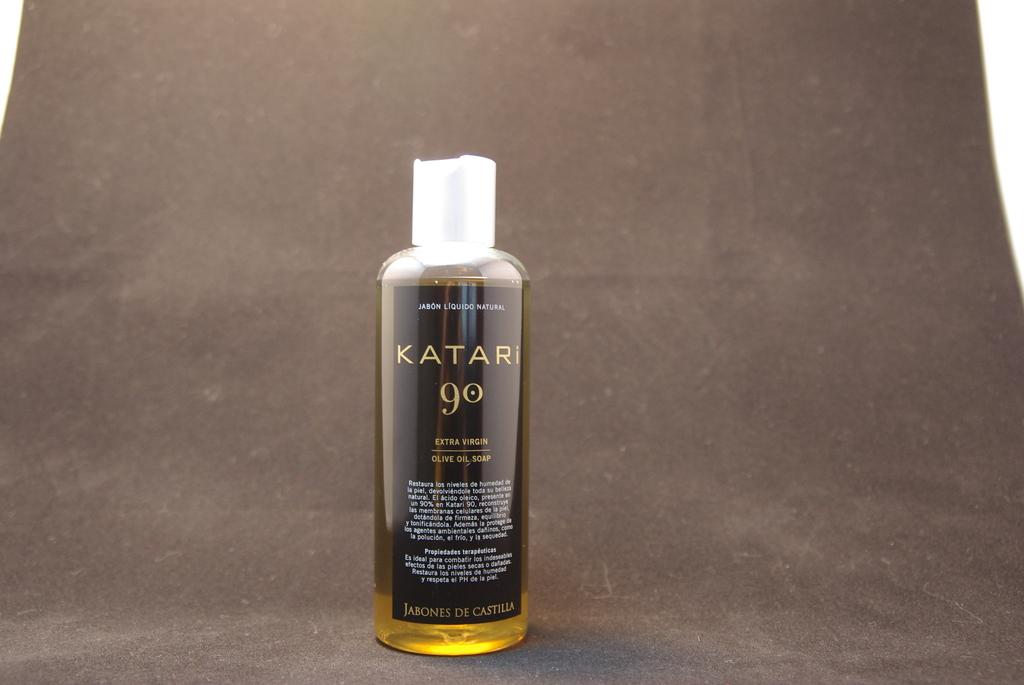<image>
Present a compact description of the photo's key features. A bottle of extra virgin olive oil soap is displayed on a grey background. 